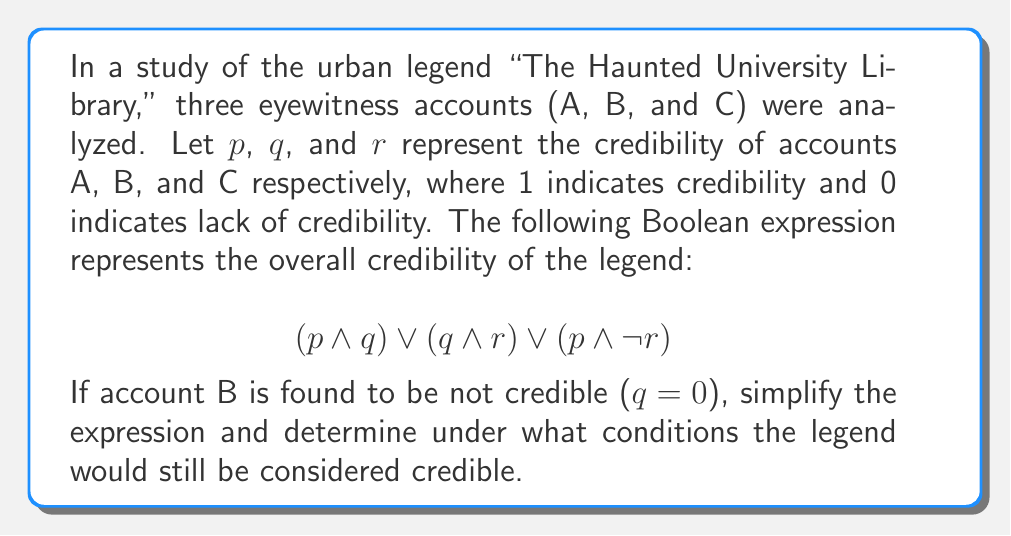Can you solve this math problem? Let's approach this step-by-step:

1) Given: $q = 0$ (Account B is not credible)

2) Substitute $q = 0$ into the original expression:
   $$(p \land 0) \lor (0 \land r) \lor (p \land \neg r)$$

3) Simplify using Boolean algebra laws:
   - $p \land 0 = 0$ (Zero law)
   - $0 \land r = 0$ (Zero law)
   
   This leaves us with:
   $$0 \lor 0 \lor (p \land \neg r)$$

4) Simplify further:
   $$0 \lor (p \land \neg r)$$ (Identity law)
   
   $$(p \land \neg r)$$ (Identity law)

5) This simplified expression means the legend is credible if account A is credible ($p = 1$) AND account C is not credible ($r = 0$).

6) We can verify this:
   - If $p = 1$ and $r = 0$: $(1 \land \neg 0) = (1 \land 1) = 1$
   - If $p = 0$ or $r = 1$: The expression evaluates to 0

Therefore, the legend would still be considered credible only when account A is credible and account C is not credible, despite account B being not credible.
Answer: $p \land \neg r$ 